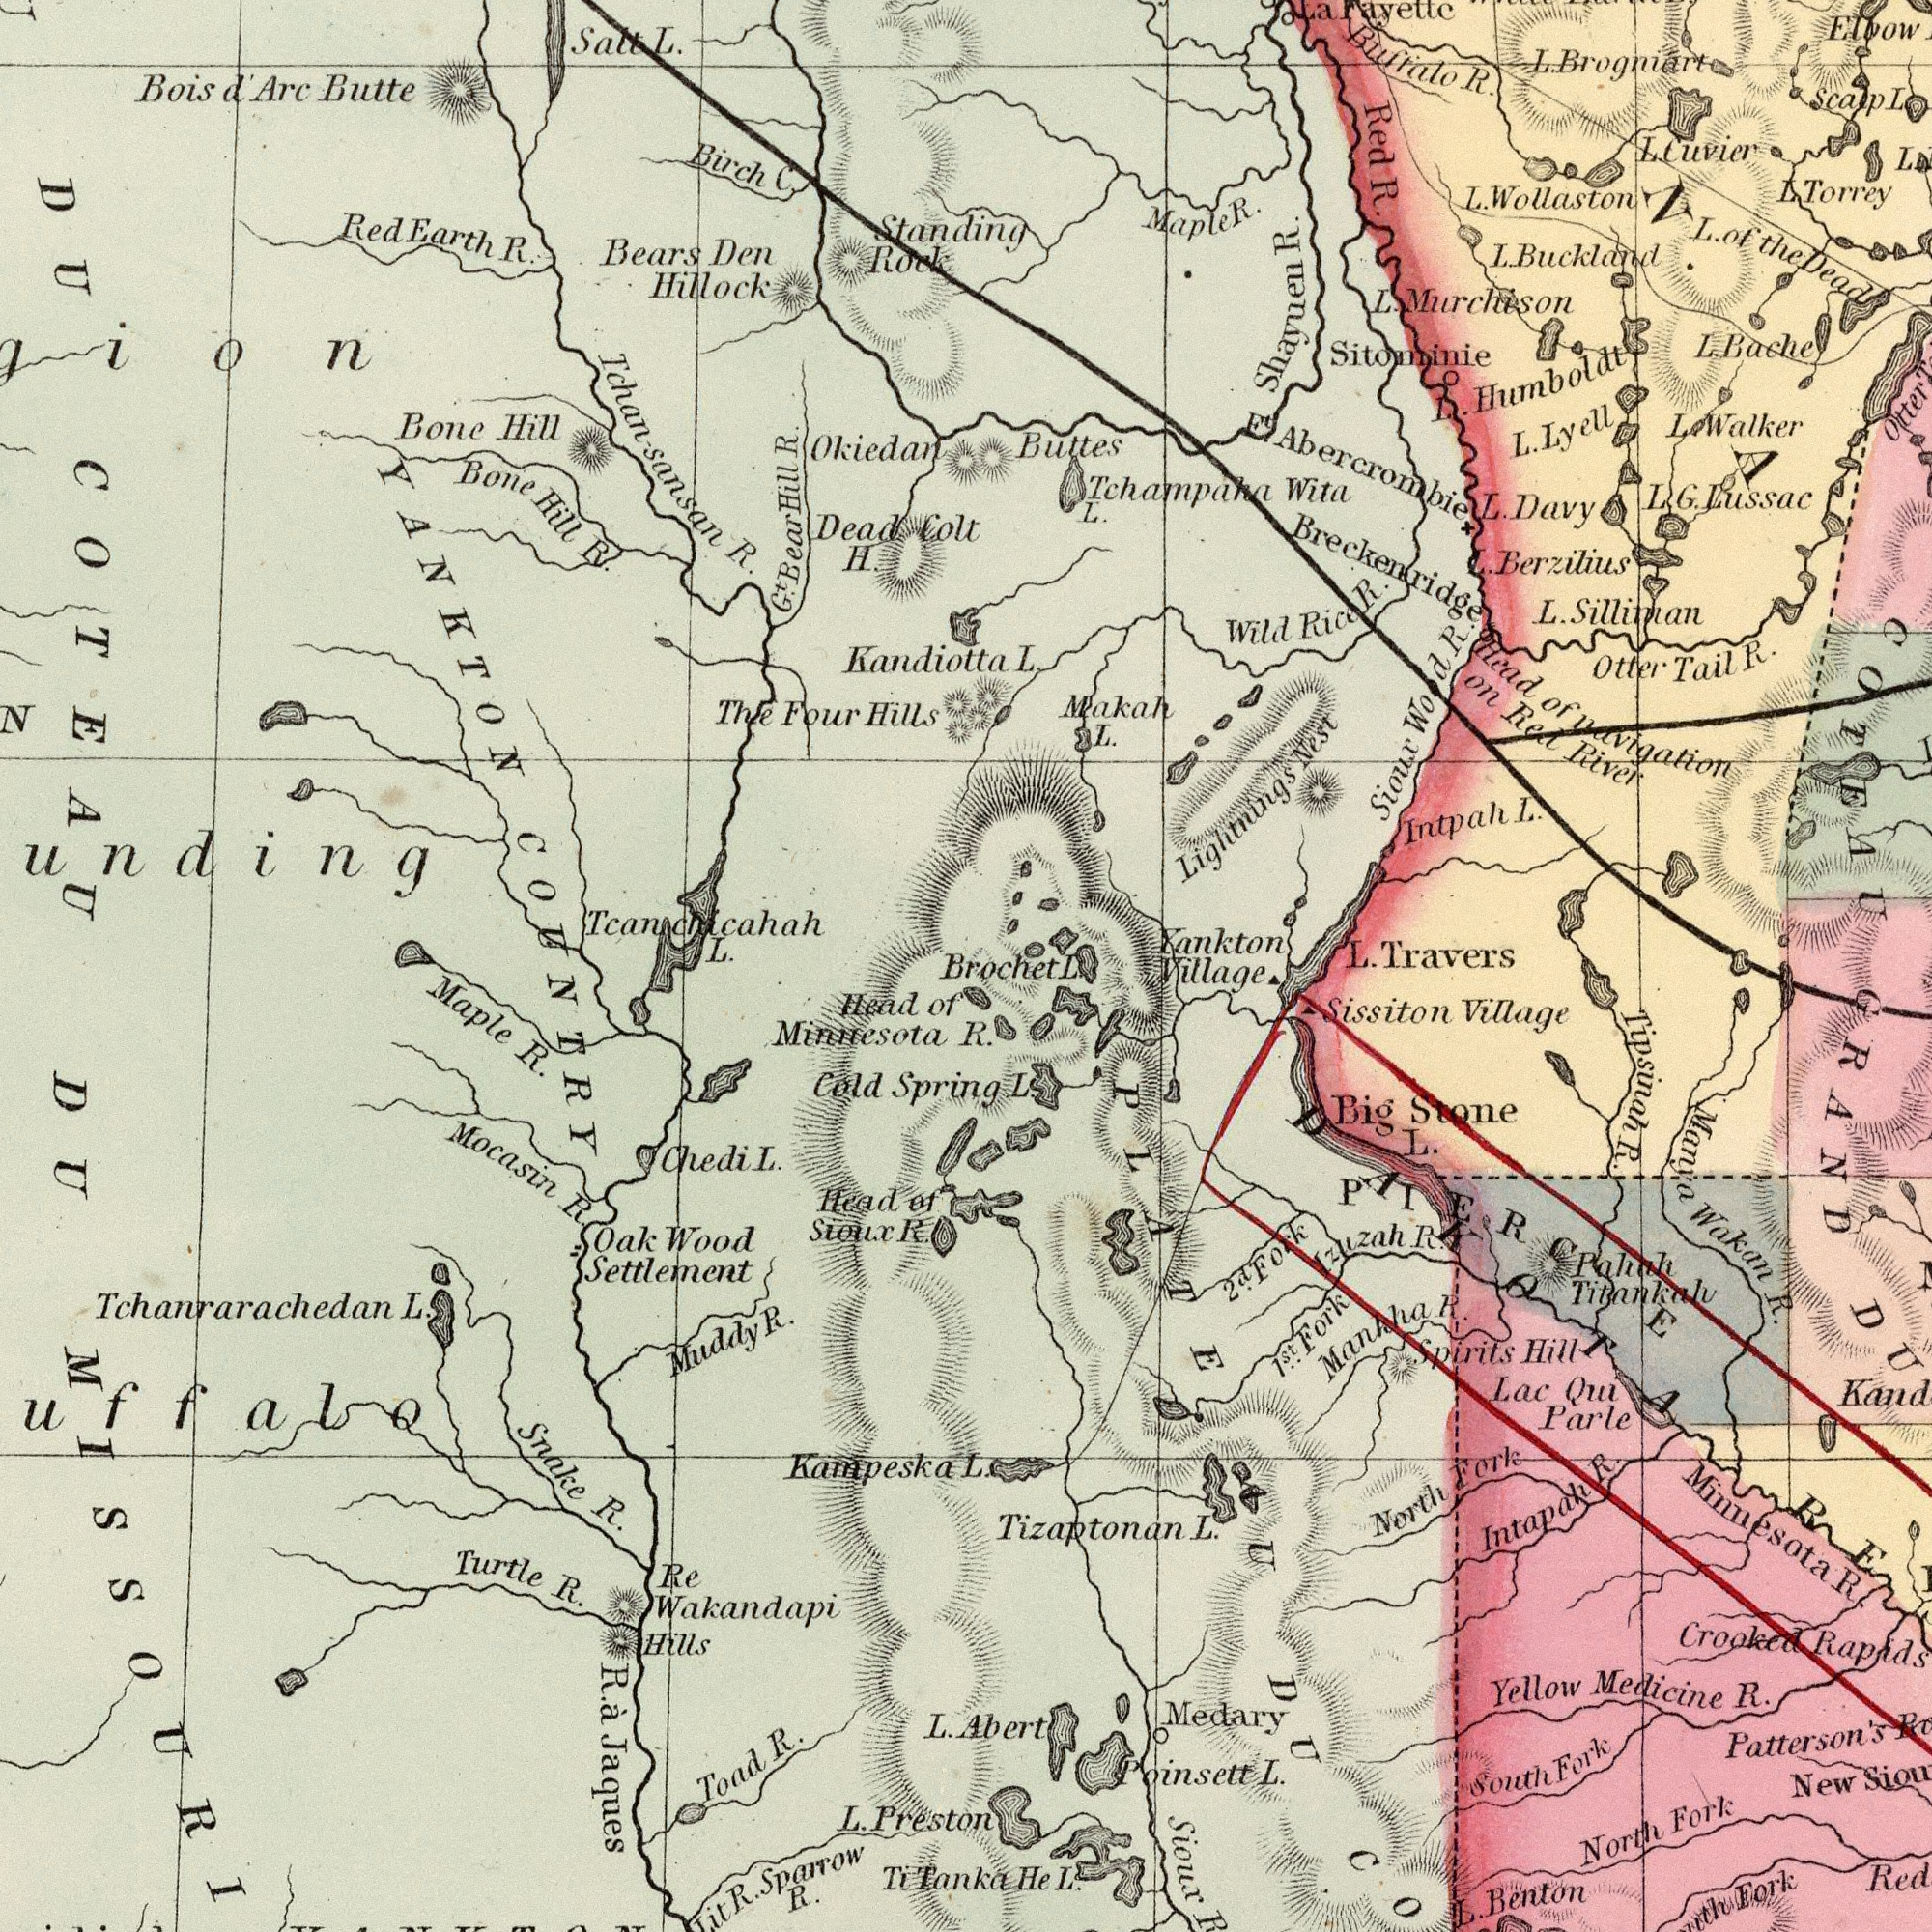What text is visible in the upper-right corner? Buttes L Sitominie Red R. Tchampaha Wita L. Maple R. Yankton Shayuen R. L. Buckland Buffalo R. L. Wollaston L. Brogniort Head of navigation on Red River Intpah L. Makah L. L. G. Lussac L. Murchison L. Berxilius L. Silliman L. Travers Wild Rice R. Otter Tail R. Lightnings Nest L. Torrey Sioux Wood R. Breckenridge L. Humboldt L. Davy Elbow L. Bache E<sup>t</sup>. Abercrombie Scalp L. La Fayettc COTEAU L. Lyell L. Walker L. of the Dead L. Cuvier Otter Brochet L. ###NA### What text is shown in the bottom-left quadrant? COUNTRY DU UISSOURI Re Wakandapi Hills Oak Wood Settlement R. ἀ Jaques Snake R. Muddy R. Maple R. L. Prest Head of Minicesota Mocasin R. L. Toad R. Turtle R. Sparrow R. Cold Spri Head of Sioux R. Chedi L. Tchanrarachedan L. Ti Tanka R. Kampeska What text can you see in the bottom-right section? Village GRAND R. Abert L. He L. L. Patterson's Sioux Manya Wakan R. Crooked Rapids Sissiton Village Poinsett L. Lac Qui Parle Yellow Medicine R. Medary L. Benton North Fork Big Stone L. Mankha R. Pahah Titankalu New Tipsinah R. Intapah R. Fork North Fork Spirits Hill South Fork 1<sup>st</sup>.. Fork Izuzah R. Tizaptonan L. AU DU Minnesota R. 2<sup>d</sup>. Fork DAKOTA PIERCE What text is visible in the upper-left corner? Bears Den Hillock Tchan-sansan R. Bone Hill R. Standing Rock The Four Hills Okiedan Dead Colt H. Red Earth R. Kandiotta Bois d' Arc Butte Salt L. Tcanchicahah L. Bone Hill Birch C. YANKTON ###unding DU COTEAU G<sup>t</sup>. Bear Hill R. 